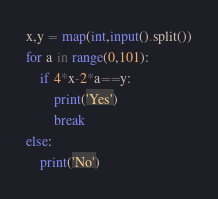Convert code to text. <code><loc_0><loc_0><loc_500><loc_500><_Python_>x,y = map(int,input().split())
for a in range(0,101):
    if 4*x-2*a==y:
        print('Yes')
        break
else:
    print('No')</code> 